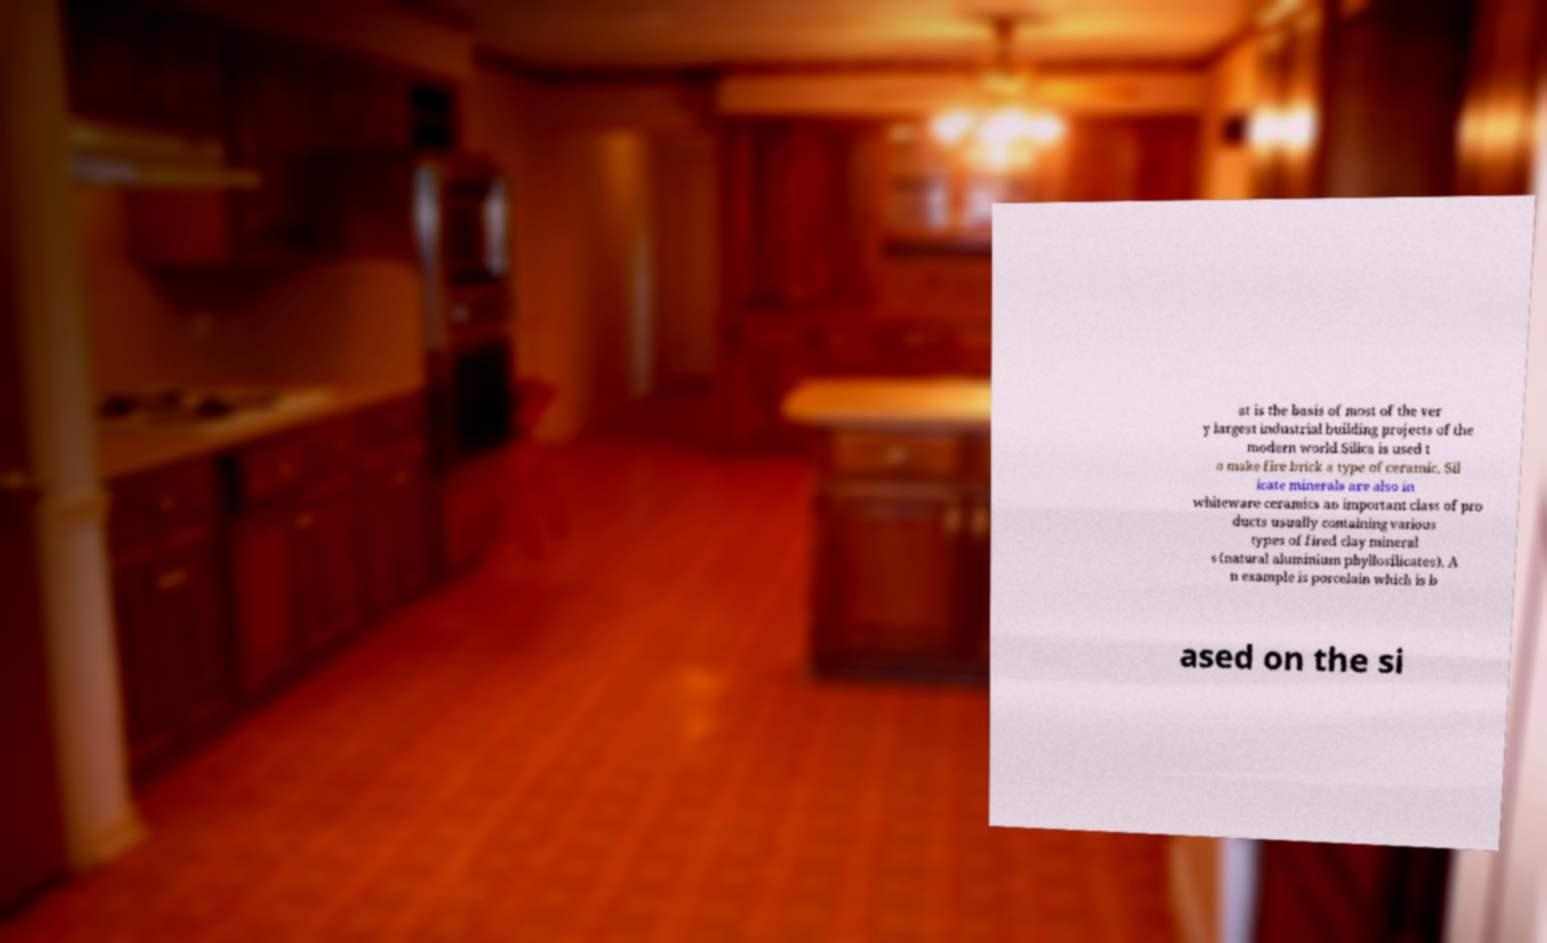Please identify and transcribe the text found in this image. at is the basis of most of the ver y largest industrial building projects of the modern world.Silica is used t o make fire brick a type of ceramic. Sil icate minerals are also in whiteware ceramics an important class of pro ducts usually containing various types of fired clay mineral s (natural aluminium phyllosilicates). A n example is porcelain which is b ased on the si 